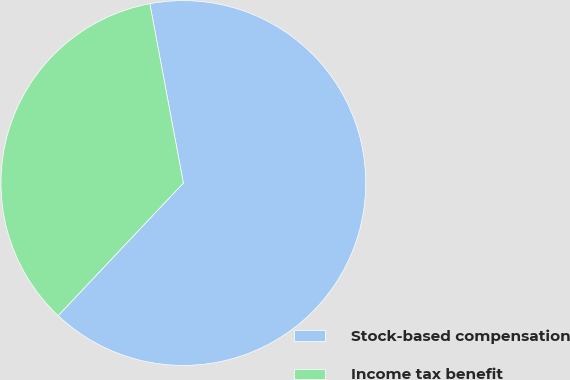Convert chart to OTSL. <chart><loc_0><loc_0><loc_500><loc_500><pie_chart><fcel>Stock-based compensation<fcel>Income tax benefit<nl><fcel>64.98%<fcel>35.02%<nl></chart> 